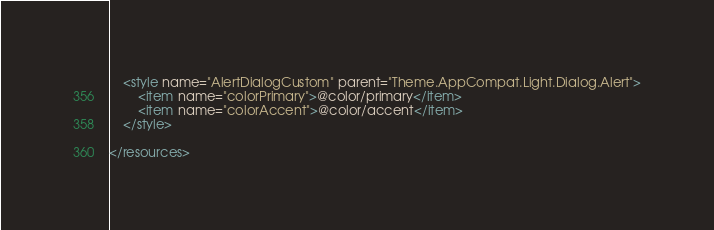Convert code to text. <code><loc_0><loc_0><loc_500><loc_500><_XML_>    <style name="AlertDialogCustom" parent="Theme.AppCompat.Light.Dialog.Alert">
        <item name="colorPrimary">@color/primary</item>
        <item name="colorAccent">@color/accent</item>
    </style>

</resources>
</code> 